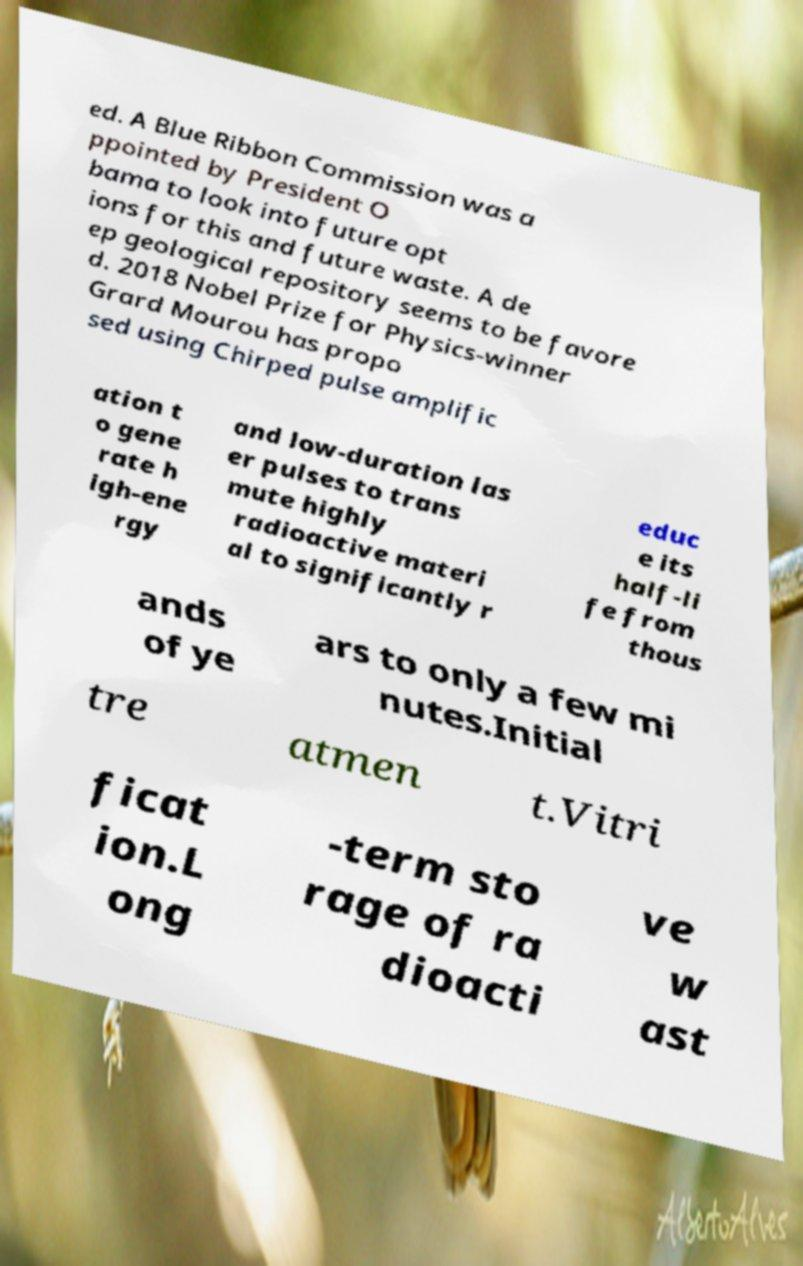For documentation purposes, I need the text within this image transcribed. Could you provide that? ed. A Blue Ribbon Commission was a ppointed by President O bama to look into future opt ions for this and future waste. A de ep geological repository seems to be favore d. 2018 Nobel Prize for Physics-winner Grard Mourou has propo sed using Chirped pulse amplific ation t o gene rate h igh-ene rgy and low-duration las er pulses to trans mute highly radioactive materi al to significantly r educ e its half-li fe from thous ands of ye ars to only a few mi nutes.Initial tre atmen t.Vitri ficat ion.L ong -term sto rage of ra dioacti ve w ast 